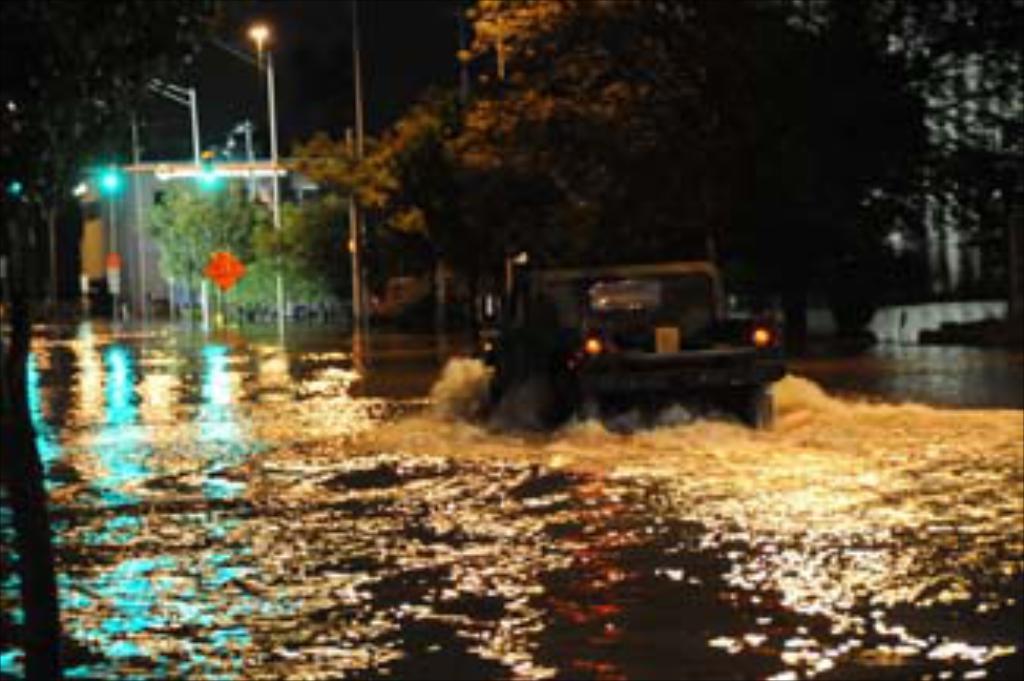Could you give a brief overview of what you see in this image? In this image I can see the vehicle in the water. In the background I can see few trees, light poles and the sky is in black color. 